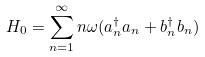<formula> <loc_0><loc_0><loc_500><loc_500>H _ { 0 } = \sum _ { n = 1 } ^ { \infty } n \omega ( a _ { n } ^ { \dagger } a _ { n } + b _ { n } ^ { \dagger } b _ { n } )</formula> 